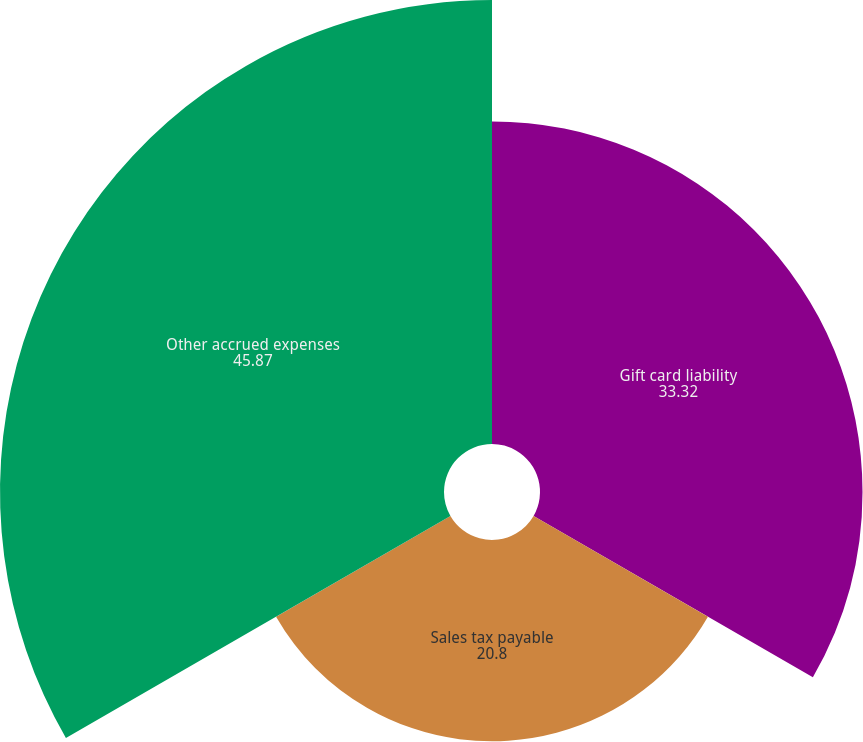Convert chart. <chart><loc_0><loc_0><loc_500><loc_500><pie_chart><fcel>Gift card liability<fcel>Sales tax payable<fcel>Other accrued expenses<nl><fcel>33.32%<fcel>20.8%<fcel>45.87%<nl></chart> 